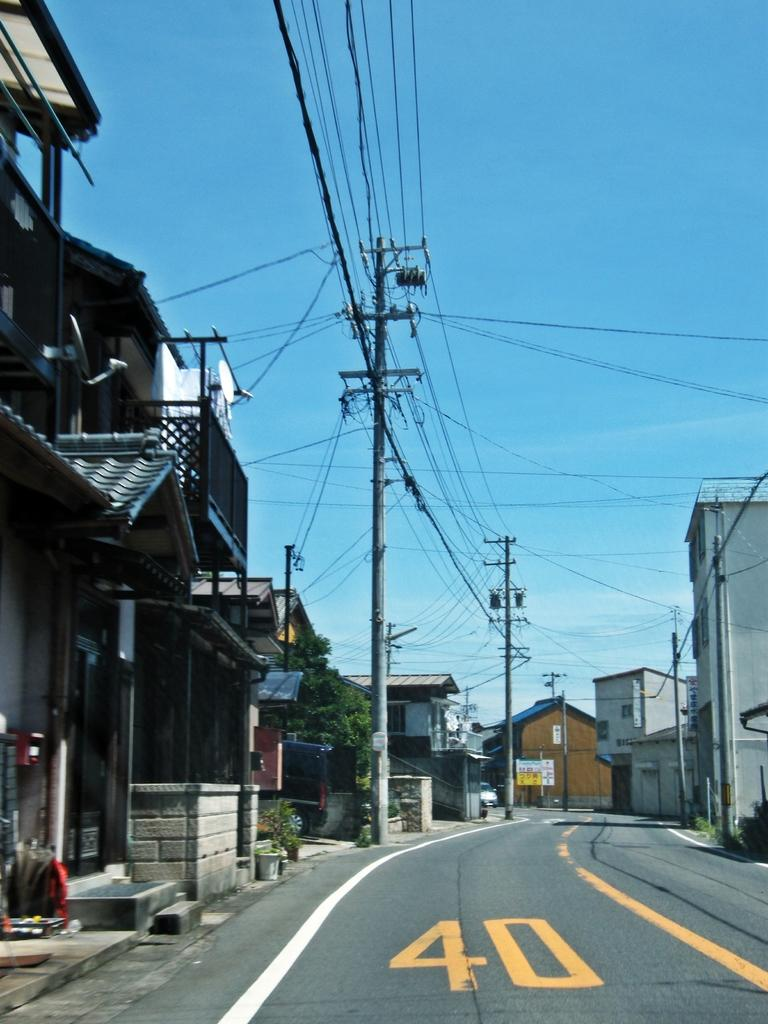What is the main feature of the image? There is a road in the image. What structures are present alongside the road? Current poles and buildings are present in the image. What else can be seen in the image? Wires, plants, and leaves are visible in the image. What is visible in the background of the image? The sky is visible in the background of the image. What type of farm animals can be seen grazing in the image? There is no farm or farm animals present in the image. What treatment is being administered to the plants in the image? There is no treatment being administered to the plants in the image; they are simply growing naturally. 